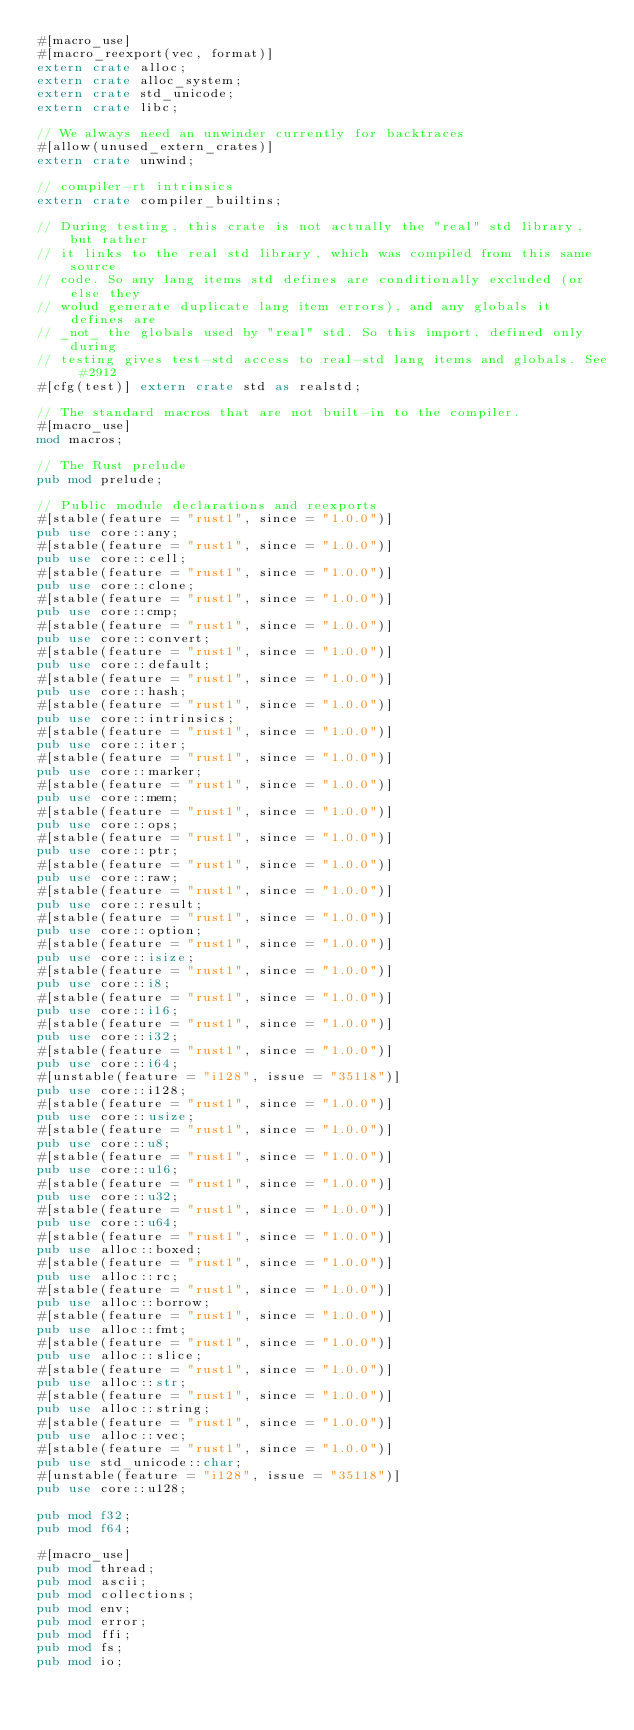<code> <loc_0><loc_0><loc_500><loc_500><_Rust_>#[macro_use]
#[macro_reexport(vec, format)]
extern crate alloc;
extern crate alloc_system;
extern crate std_unicode;
extern crate libc;

// We always need an unwinder currently for backtraces
#[allow(unused_extern_crates)]
extern crate unwind;

// compiler-rt intrinsics
extern crate compiler_builtins;

// During testing, this crate is not actually the "real" std library, but rather
// it links to the real std library, which was compiled from this same source
// code. So any lang items std defines are conditionally excluded (or else they
// wolud generate duplicate lang item errors), and any globals it defines are
// _not_ the globals used by "real" std. So this import, defined only during
// testing gives test-std access to real-std lang items and globals. See #2912
#[cfg(test)] extern crate std as realstd;

// The standard macros that are not built-in to the compiler.
#[macro_use]
mod macros;

// The Rust prelude
pub mod prelude;

// Public module declarations and reexports
#[stable(feature = "rust1", since = "1.0.0")]
pub use core::any;
#[stable(feature = "rust1", since = "1.0.0")]
pub use core::cell;
#[stable(feature = "rust1", since = "1.0.0")]
pub use core::clone;
#[stable(feature = "rust1", since = "1.0.0")]
pub use core::cmp;
#[stable(feature = "rust1", since = "1.0.0")]
pub use core::convert;
#[stable(feature = "rust1", since = "1.0.0")]
pub use core::default;
#[stable(feature = "rust1", since = "1.0.0")]
pub use core::hash;
#[stable(feature = "rust1", since = "1.0.0")]
pub use core::intrinsics;
#[stable(feature = "rust1", since = "1.0.0")]
pub use core::iter;
#[stable(feature = "rust1", since = "1.0.0")]
pub use core::marker;
#[stable(feature = "rust1", since = "1.0.0")]
pub use core::mem;
#[stable(feature = "rust1", since = "1.0.0")]
pub use core::ops;
#[stable(feature = "rust1", since = "1.0.0")]
pub use core::ptr;
#[stable(feature = "rust1", since = "1.0.0")]
pub use core::raw;
#[stable(feature = "rust1", since = "1.0.0")]
pub use core::result;
#[stable(feature = "rust1", since = "1.0.0")]
pub use core::option;
#[stable(feature = "rust1", since = "1.0.0")]
pub use core::isize;
#[stable(feature = "rust1", since = "1.0.0")]
pub use core::i8;
#[stable(feature = "rust1", since = "1.0.0")]
pub use core::i16;
#[stable(feature = "rust1", since = "1.0.0")]
pub use core::i32;
#[stable(feature = "rust1", since = "1.0.0")]
pub use core::i64;
#[unstable(feature = "i128", issue = "35118")]
pub use core::i128;
#[stable(feature = "rust1", since = "1.0.0")]
pub use core::usize;
#[stable(feature = "rust1", since = "1.0.0")]
pub use core::u8;
#[stable(feature = "rust1", since = "1.0.0")]
pub use core::u16;
#[stable(feature = "rust1", since = "1.0.0")]
pub use core::u32;
#[stable(feature = "rust1", since = "1.0.0")]
pub use core::u64;
#[stable(feature = "rust1", since = "1.0.0")]
pub use alloc::boxed;
#[stable(feature = "rust1", since = "1.0.0")]
pub use alloc::rc;
#[stable(feature = "rust1", since = "1.0.0")]
pub use alloc::borrow;
#[stable(feature = "rust1", since = "1.0.0")]
pub use alloc::fmt;
#[stable(feature = "rust1", since = "1.0.0")]
pub use alloc::slice;
#[stable(feature = "rust1", since = "1.0.0")]
pub use alloc::str;
#[stable(feature = "rust1", since = "1.0.0")]
pub use alloc::string;
#[stable(feature = "rust1", since = "1.0.0")]
pub use alloc::vec;
#[stable(feature = "rust1", since = "1.0.0")]
pub use std_unicode::char;
#[unstable(feature = "i128", issue = "35118")]
pub use core::u128;

pub mod f32;
pub mod f64;

#[macro_use]
pub mod thread;
pub mod ascii;
pub mod collections;
pub mod env;
pub mod error;
pub mod ffi;
pub mod fs;
pub mod io;</code> 